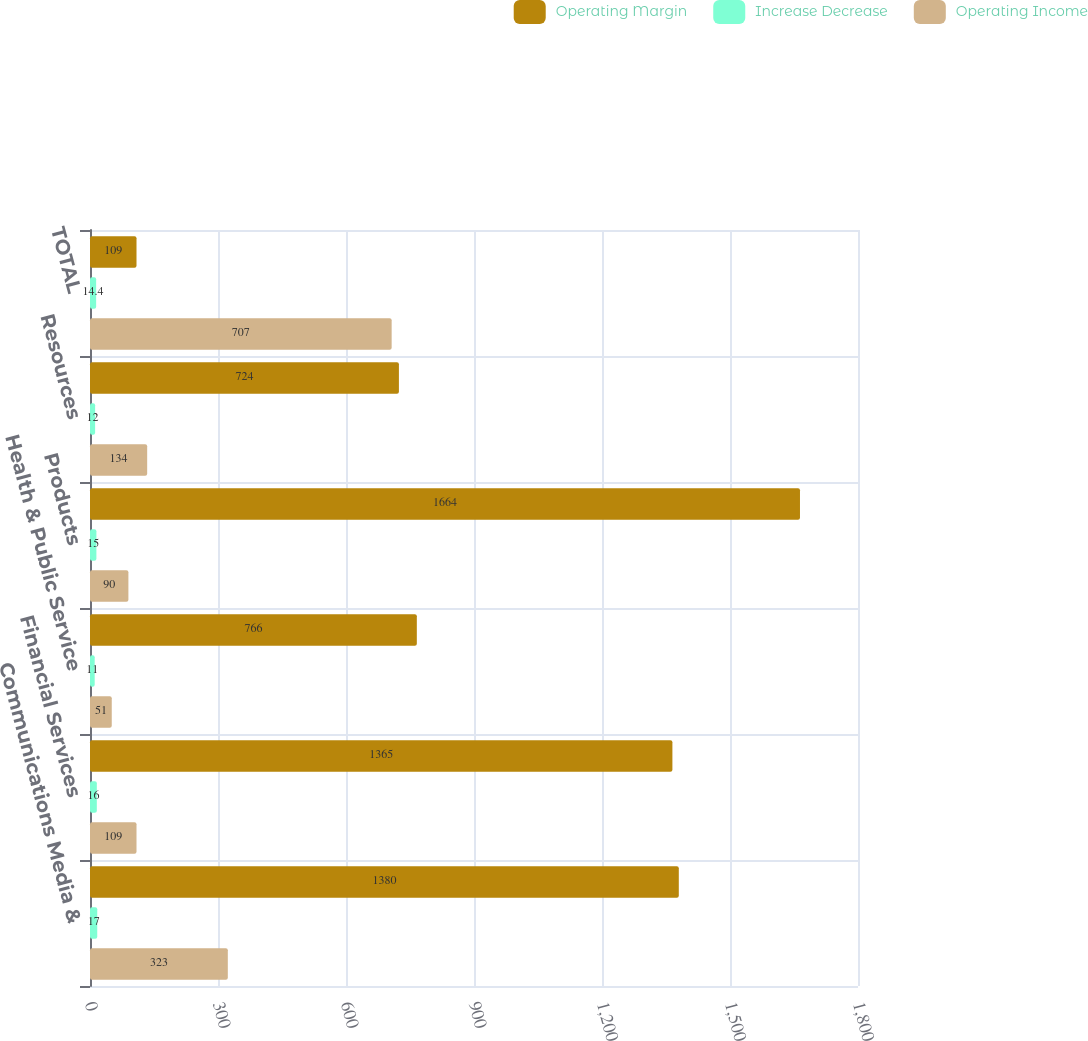Convert chart. <chart><loc_0><loc_0><loc_500><loc_500><stacked_bar_chart><ecel><fcel>Communications Media &<fcel>Financial Services<fcel>Health & Public Service<fcel>Products<fcel>Resources<fcel>TOTAL<nl><fcel>Operating Margin<fcel>1380<fcel>1365<fcel>766<fcel>1664<fcel>724<fcel>109<nl><fcel>Increase Decrease<fcel>17<fcel>16<fcel>11<fcel>15<fcel>12<fcel>14.4<nl><fcel>Operating Income<fcel>323<fcel>109<fcel>51<fcel>90<fcel>134<fcel>707<nl></chart> 